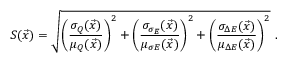<formula> <loc_0><loc_0><loc_500><loc_500>S ( \vec { x } ) = \sqrt { \left ( { \frac { \sigma _ { Q } ( \vec { x } ) } { \mu _ { Q } ( \vec { x } ) } } \right ) ^ { 2 } + \left ( { \frac { \sigma _ { \sigma _ { E } } ( { \vec { x } } ) } { \mu _ { \sigma E } ( { \vec { x } } ) } } \right ) ^ { 2 } + \left ( { \frac { \sigma _ { \Delta E } ( { \vec { x } } ) } { \mu _ { \Delta E } ( { \vec { x } } ) } } \right ) ^ { 2 } } \ .</formula> 